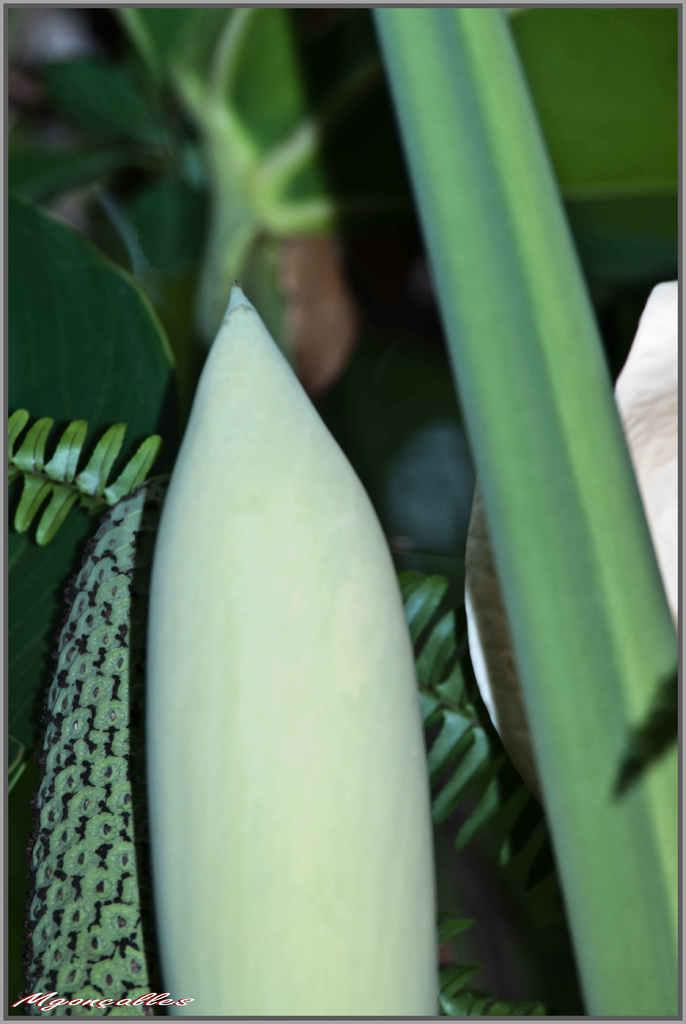What type of living organism can be seen in the picture? There is a plant in the picture. What else is present in the picture besides the plant? There is a fruit in the picture. Where is the text located in the picture? The text is at the bottom left corner of the picture. What type of territory is being claimed by the plant in the picture? There is no indication in the image that the plant is claiming any territory. 